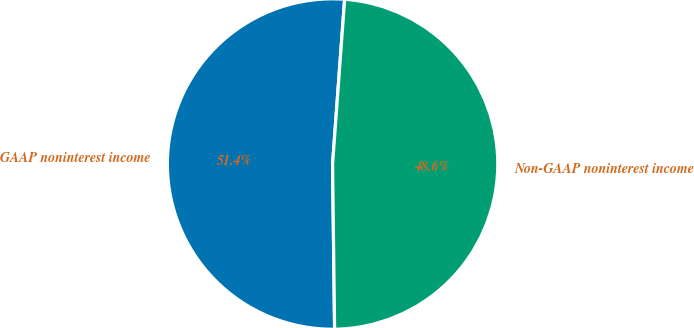<chart> <loc_0><loc_0><loc_500><loc_500><pie_chart><fcel>GAAP noninterest income<fcel>Non-GAAP noninterest income<nl><fcel>51.36%<fcel>48.64%<nl></chart> 